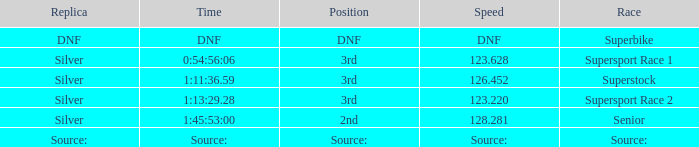Which race has a position of 3rd and a speed of 123.628? Supersport Race 1. 